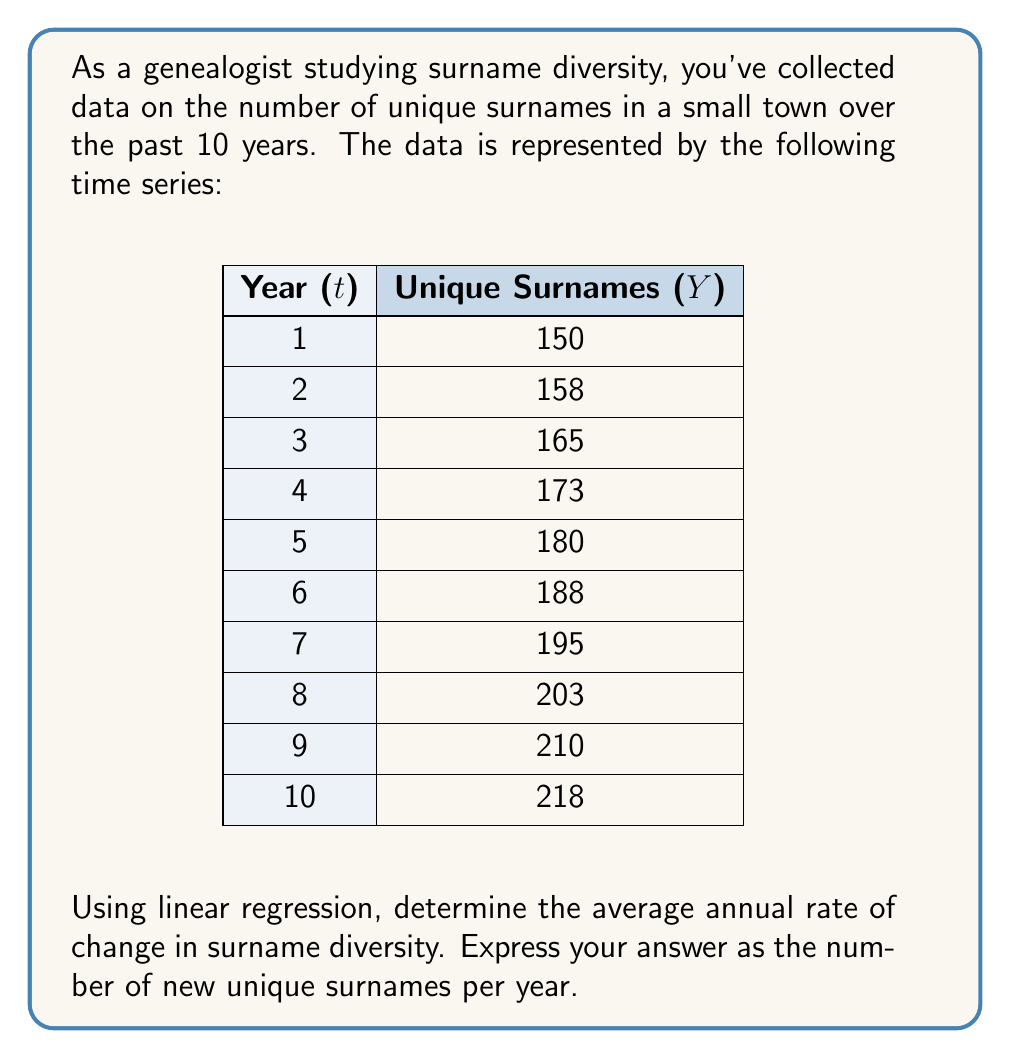Help me with this question. To solve this problem, we'll use simple linear regression to fit a straight line to the time series data. The slope of this line will represent the average annual rate of change in surname diversity.

1) First, let's define our variables:
   $t$ = time (year)
   $Y$ = number of unique surnames

2) The linear regression model is:
   $Y = \beta_0 + \beta_1t + \epsilon$

   Where $\beta_0$ is the y-intercept, $\beta_1$ is the slope (our rate of change), and $\epsilon$ is the error term.

3) To find $\beta_1$, we can use the formula:

   $$\beta_1 = \frac{n\sum{tY} - \sum{t}\sum{Y}}{n\sum{t^2} - (\sum{t})^2}$$

   Where $n$ is the number of data points (10 in this case).

4) Let's calculate the necessary sums:
   $\sum{t} = 55$
   $\sum{Y} = 1840$
   $\sum{tY} = 18,645$
   $\sum{t^2} = 385$

5) Now, let's substitute these values into our formula:

   $$\beta_1 = \frac{10(18,645) - 55(1840)}{10(385) - 55^2}$$

6) Simplifying:

   $$\beta_1 = \frac{186,450 - 101,200}{3850 - 3025} = \frac{85,250}{825} = 7.6$$

Thus, the average annual rate of change in surname diversity is 7.6 new unique surnames per year.
Answer: 7.6 new unique surnames per year 